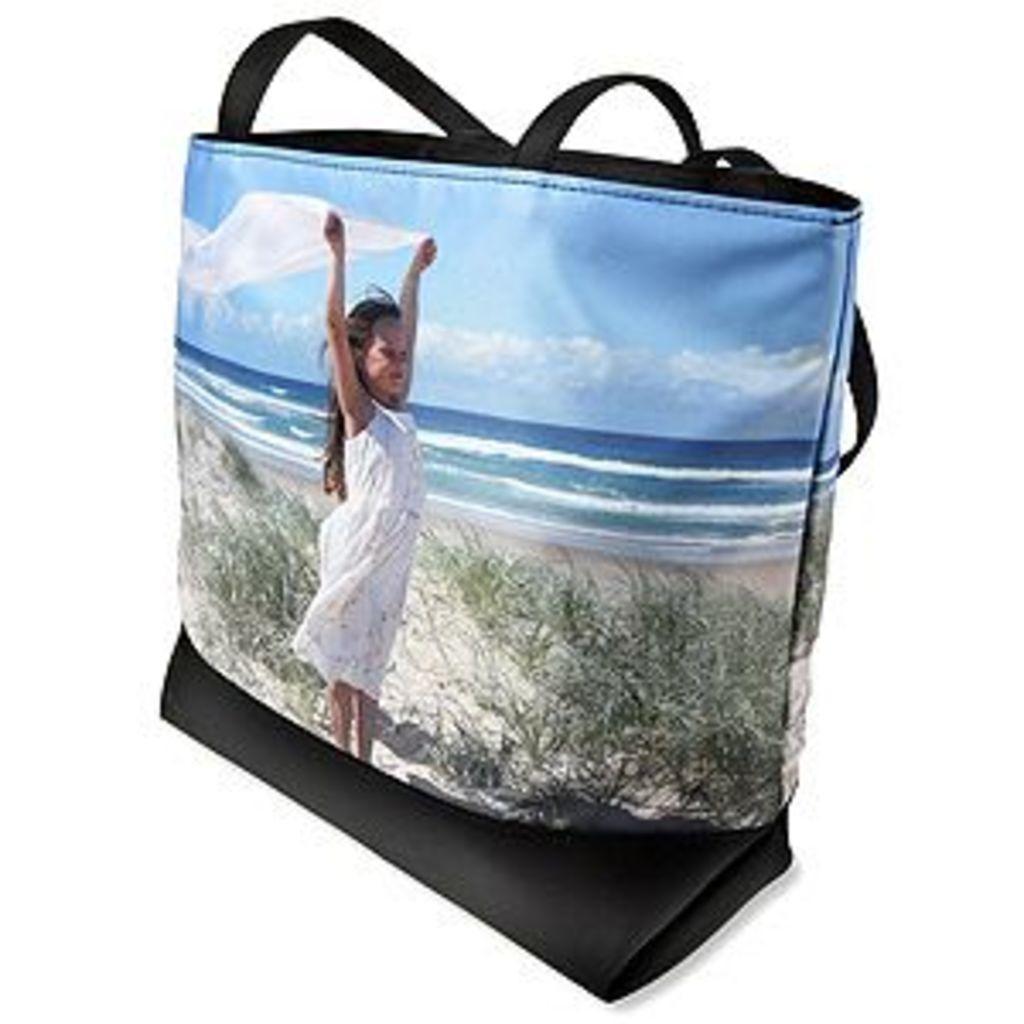Could you give a brief overview of what you see in this image? This is a bag on which there is a photo of a kid holding scarf in her hands and we can see sky,clouds,water and plants on it. 